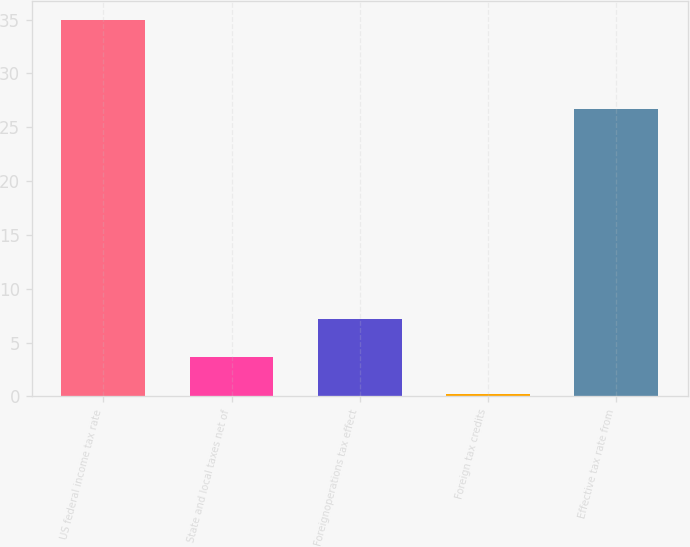Convert chart to OTSL. <chart><loc_0><loc_0><loc_500><loc_500><bar_chart><fcel>US federal income tax rate<fcel>State and local taxes net of<fcel>Foreignoperations tax effect<fcel>Foreign tax credits<fcel>Effective tax rate from<nl><fcel>35<fcel>3.68<fcel>7.16<fcel>0.2<fcel>26.7<nl></chart> 